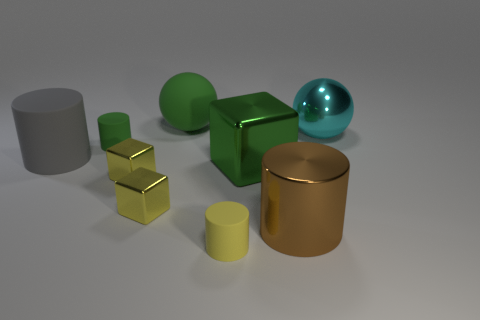Is the color of the large matte ball the same as the large shiny block?
Provide a succinct answer. Yes. Is there anything else that is the same color as the big rubber ball?
Give a very brief answer. Yes. Does the gray cylinder have the same material as the green object that is in front of the small green cylinder?
Give a very brief answer. No. What number of big gray objects are the same shape as the tiny green object?
Your response must be concise. 1. There is a brown thing; is it the same shape as the thing behind the metal ball?
Offer a terse response. No. There is a large brown cylinder; how many big gray cylinders are on the right side of it?
Make the answer very short. 0. Is there a green matte object of the same size as the metallic sphere?
Your answer should be very brief. Yes. Do the big metallic thing that is to the right of the brown metallic cylinder and the big brown metallic object have the same shape?
Provide a short and direct response. No. What is the color of the matte sphere?
Your answer should be very brief. Green. There is a small object that is the same color as the big metal block; what is its shape?
Make the answer very short. Cylinder. 